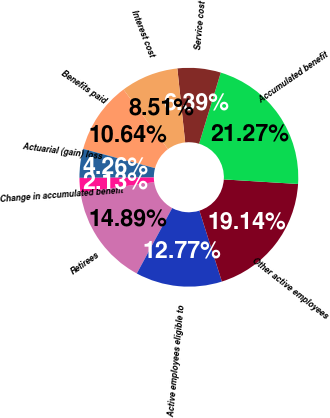<chart> <loc_0><loc_0><loc_500><loc_500><pie_chart><fcel>Retirees<fcel>Active employees eligible to<fcel>Other active employees<fcel>Accumulated benefit<fcel>Service cost<fcel>Interest cost<fcel>Benefits paid<fcel>Actuarial (gain) loss<fcel>Change in accumulated benefit<nl><fcel>14.89%<fcel>12.77%<fcel>19.14%<fcel>21.27%<fcel>6.39%<fcel>8.51%<fcel>10.64%<fcel>4.26%<fcel>2.13%<nl></chart> 